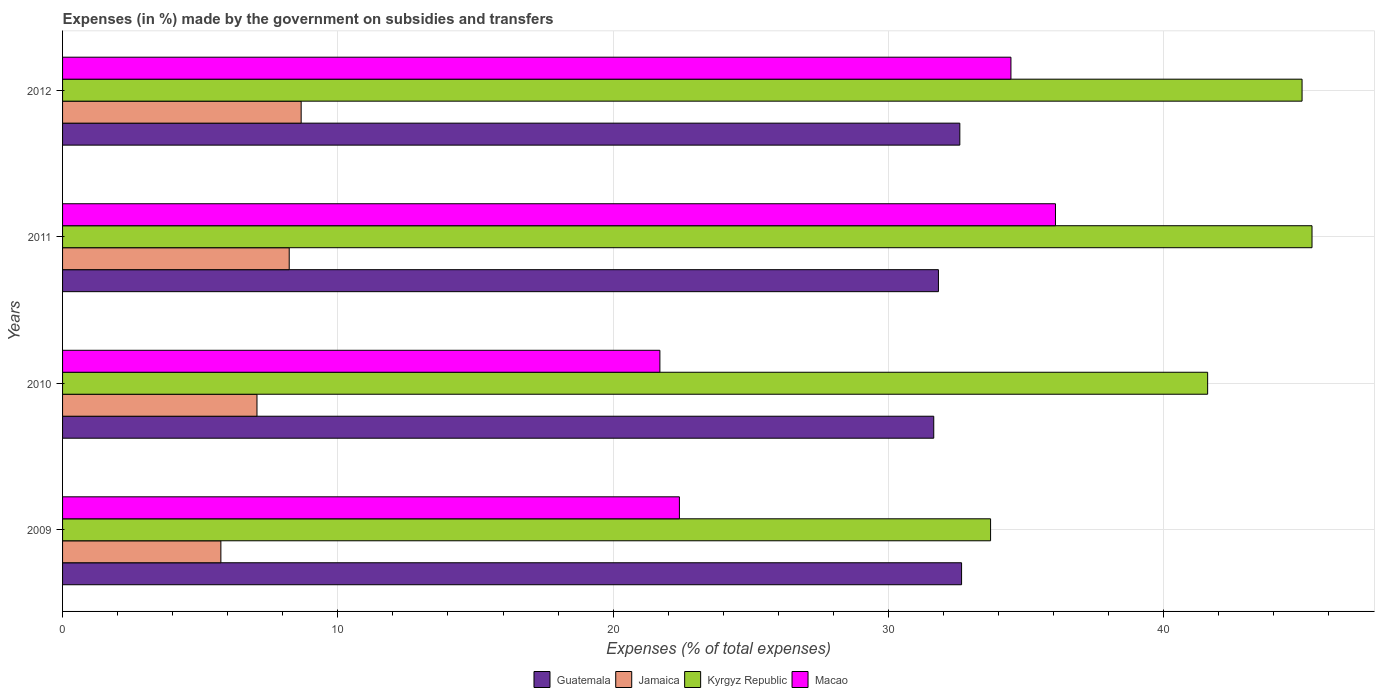How many different coloured bars are there?
Ensure brevity in your answer.  4. How many groups of bars are there?
Offer a very short reply. 4. Are the number of bars on each tick of the Y-axis equal?
Ensure brevity in your answer.  Yes. How many bars are there on the 3rd tick from the top?
Offer a very short reply. 4. What is the label of the 1st group of bars from the top?
Your answer should be very brief. 2012. What is the percentage of expenses made by the government on subsidies and transfers in Kyrgyz Republic in 2012?
Provide a short and direct response. 45.03. Across all years, what is the maximum percentage of expenses made by the government on subsidies and transfers in Jamaica?
Ensure brevity in your answer.  8.67. Across all years, what is the minimum percentage of expenses made by the government on subsidies and transfers in Guatemala?
Ensure brevity in your answer.  31.65. In which year was the percentage of expenses made by the government on subsidies and transfers in Kyrgyz Republic maximum?
Your answer should be compact. 2011. In which year was the percentage of expenses made by the government on subsidies and transfers in Jamaica minimum?
Your answer should be compact. 2009. What is the total percentage of expenses made by the government on subsidies and transfers in Macao in the graph?
Your response must be concise. 114.63. What is the difference between the percentage of expenses made by the government on subsidies and transfers in Jamaica in 2011 and that in 2012?
Offer a terse response. -0.43. What is the difference between the percentage of expenses made by the government on subsidies and transfers in Jamaica in 2010 and the percentage of expenses made by the government on subsidies and transfers in Guatemala in 2012?
Offer a very short reply. -25.53. What is the average percentage of expenses made by the government on subsidies and transfers in Guatemala per year?
Ensure brevity in your answer.  32.18. In the year 2010, what is the difference between the percentage of expenses made by the government on subsidies and transfers in Kyrgyz Republic and percentage of expenses made by the government on subsidies and transfers in Jamaica?
Keep it short and to the point. 34.53. What is the ratio of the percentage of expenses made by the government on subsidies and transfers in Kyrgyz Republic in 2009 to that in 2012?
Give a very brief answer. 0.75. What is the difference between the highest and the second highest percentage of expenses made by the government on subsidies and transfers in Guatemala?
Keep it short and to the point. 0.06. What is the difference between the highest and the lowest percentage of expenses made by the government on subsidies and transfers in Jamaica?
Your answer should be compact. 2.92. What does the 4th bar from the top in 2012 represents?
Provide a succinct answer. Guatemala. What does the 4th bar from the bottom in 2012 represents?
Your answer should be very brief. Macao. Is it the case that in every year, the sum of the percentage of expenses made by the government on subsidies and transfers in Guatemala and percentage of expenses made by the government on subsidies and transfers in Macao is greater than the percentage of expenses made by the government on subsidies and transfers in Kyrgyz Republic?
Provide a succinct answer. Yes. Are all the bars in the graph horizontal?
Offer a very short reply. Yes. Are the values on the major ticks of X-axis written in scientific E-notation?
Offer a terse response. No. Does the graph contain grids?
Ensure brevity in your answer.  Yes. What is the title of the graph?
Provide a short and direct response. Expenses (in %) made by the government on subsidies and transfers. What is the label or title of the X-axis?
Provide a short and direct response. Expenses (% of total expenses). What is the label or title of the Y-axis?
Your answer should be compact. Years. What is the Expenses (% of total expenses) in Guatemala in 2009?
Offer a terse response. 32.66. What is the Expenses (% of total expenses) in Jamaica in 2009?
Keep it short and to the point. 5.75. What is the Expenses (% of total expenses) in Kyrgyz Republic in 2009?
Give a very brief answer. 33.71. What is the Expenses (% of total expenses) of Macao in 2009?
Keep it short and to the point. 22.41. What is the Expenses (% of total expenses) of Guatemala in 2010?
Keep it short and to the point. 31.65. What is the Expenses (% of total expenses) in Jamaica in 2010?
Give a very brief answer. 7.06. What is the Expenses (% of total expenses) in Kyrgyz Republic in 2010?
Offer a very short reply. 41.6. What is the Expenses (% of total expenses) in Macao in 2010?
Your answer should be compact. 21.7. What is the Expenses (% of total expenses) of Guatemala in 2011?
Provide a succinct answer. 31.82. What is the Expenses (% of total expenses) in Jamaica in 2011?
Give a very brief answer. 8.23. What is the Expenses (% of total expenses) of Kyrgyz Republic in 2011?
Make the answer very short. 45.39. What is the Expenses (% of total expenses) in Macao in 2011?
Ensure brevity in your answer.  36.07. What is the Expenses (% of total expenses) in Guatemala in 2012?
Provide a succinct answer. 32.59. What is the Expenses (% of total expenses) of Jamaica in 2012?
Ensure brevity in your answer.  8.67. What is the Expenses (% of total expenses) of Kyrgyz Republic in 2012?
Give a very brief answer. 45.03. What is the Expenses (% of total expenses) of Macao in 2012?
Provide a short and direct response. 34.45. Across all years, what is the maximum Expenses (% of total expenses) in Guatemala?
Give a very brief answer. 32.66. Across all years, what is the maximum Expenses (% of total expenses) of Jamaica?
Make the answer very short. 8.67. Across all years, what is the maximum Expenses (% of total expenses) in Kyrgyz Republic?
Provide a succinct answer. 45.39. Across all years, what is the maximum Expenses (% of total expenses) in Macao?
Your answer should be compact. 36.07. Across all years, what is the minimum Expenses (% of total expenses) in Guatemala?
Your answer should be very brief. 31.65. Across all years, what is the minimum Expenses (% of total expenses) in Jamaica?
Offer a very short reply. 5.75. Across all years, what is the minimum Expenses (% of total expenses) of Kyrgyz Republic?
Ensure brevity in your answer.  33.71. Across all years, what is the minimum Expenses (% of total expenses) in Macao?
Ensure brevity in your answer.  21.7. What is the total Expenses (% of total expenses) in Guatemala in the graph?
Ensure brevity in your answer.  128.72. What is the total Expenses (% of total expenses) in Jamaica in the graph?
Give a very brief answer. 29.71. What is the total Expenses (% of total expenses) in Kyrgyz Republic in the graph?
Provide a succinct answer. 165.72. What is the total Expenses (% of total expenses) in Macao in the graph?
Ensure brevity in your answer.  114.63. What is the difference between the Expenses (% of total expenses) in Guatemala in 2009 and that in 2010?
Make the answer very short. 1.01. What is the difference between the Expenses (% of total expenses) in Jamaica in 2009 and that in 2010?
Make the answer very short. -1.31. What is the difference between the Expenses (% of total expenses) of Kyrgyz Republic in 2009 and that in 2010?
Keep it short and to the point. -7.88. What is the difference between the Expenses (% of total expenses) in Macao in 2009 and that in 2010?
Keep it short and to the point. 0.71. What is the difference between the Expenses (% of total expenses) of Guatemala in 2009 and that in 2011?
Your answer should be compact. 0.84. What is the difference between the Expenses (% of total expenses) in Jamaica in 2009 and that in 2011?
Ensure brevity in your answer.  -2.48. What is the difference between the Expenses (% of total expenses) in Kyrgyz Republic in 2009 and that in 2011?
Provide a short and direct response. -11.68. What is the difference between the Expenses (% of total expenses) of Macao in 2009 and that in 2011?
Your answer should be compact. -13.66. What is the difference between the Expenses (% of total expenses) of Guatemala in 2009 and that in 2012?
Make the answer very short. 0.06. What is the difference between the Expenses (% of total expenses) in Jamaica in 2009 and that in 2012?
Your answer should be compact. -2.92. What is the difference between the Expenses (% of total expenses) of Kyrgyz Republic in 2009 and that in 2012?
Your answer should be very brief. -11.32. What is the difference between the Expenses (% of total expenses) in Macao in 2009 and that in 2012?
Offer a very short reply. -12.04. What is the difference between the Expenses (% of total expenses) of Guatemala in 2010 and that in 2011?
Ensure brevity in your answer.  -0.17. What is the difference between the Expenses (% of total expenses) of Jamaica in 2010 and that in 2011?
Provide a succinct answer. -1.17. What is the difference between the Expenses (% of total expenses) in Kyrgyz Republic in 2010 and that in 2011?
Keep it short and to the point. -3.79. What is the difference between the Expenses (% of total expenses) of Macao in 2010 and that in 2011?
Keep it short and to the point. -14.37. What is the difference between the Expenses (% of total expenses) in Guatemala in 2010 and that in 2012?
Make the answer very short. -0.95. What is the difference between the Expenses (% of total expenses) of Jamaica in 2010 and that in 2012?
Offer a terse response. -1.6. What is the difference between the Expenses (% of total expenses) in Kyrgyz Republic in 2010 and that in 2012?
Provide a short and direct response. -3.43. What is the difference between the Expenses (% of total expenses) in Macao in 2010 and that in 2012?
Provide a short and direct response. -12.75. What is the difference between the Expenses (% of total expenses) in Guatemala in 2011 and that in 2012?
Give a very brief answer. -0.78. What is the difference between the Expenses (% of total expenses) in Jamaica in 2011 and that in 2012?
Provide a succinct answer. -0.43. What is the difference between the Expenses (% of total expenses) in Kyrgyz Republic in 2011 and that in 2012?
Offer a terse response. 0.36. What is the difference between the Expenses (% of total expenses) of Macao in 2011 and that in 2012?
Ensure brevity in your answer.  1.62. What is the difference between the Expenses (% of total expenses) in Guatemala in 2009 and the Expenses (% of total expenses) in Jamaica in 2010?
Your response must be concise. 25.6. What is the difference between the Expenses (% of total expenses) of Guatemala in 2009 and the Expenses (% of total expenses) of Kyrgyz Republic in 2010?
Keep it short and to the point. -8.94. What is the difference between the Expenses (% of total expenses) in Guatemala in 2009 and the Expenses (% of total expenses) in Macao in 2010?
Provide a succinct answer. 10.96. What is the difference between the Expenses (% of total expenses) of Jamaica in 2009 and the Expenses (% of total expenses) of Kyrgyz Republic in 2010?
Your answer should be very brief. -35.85. What is the difference between the Expenses (% of total expenses) of Jamaica in 2009 and the Expenses (% of total expenses) of Macao in 2010?
Your response must be concise. -15.95. What is the difference between the Expenses (% of total expenses) in Kyrgyz Republic in 2009 and the Expenses (% of total expenses) in Macao in 2010?
Provide a short and direct response. 12.01. What is the difference between the Expenses (% of total expenses) in Guatemala in 2009 and the Expenses (% of total expenses) in Jamaica in 2011?
Offer a terse response. 24.42. What is the difference between the Expenses (% of total expenses) in Guatemala in 2009 and the Expenses (% of total expenses) in Kyrgyz Republic in 2011?
Ensure brevity in your answer.  -12.73. What is the difference between the Expenses (% of total expenses) in Guatemala in 2009 and the Expenses (% of total expenses) in Macao in 2011?
Your response must be concise. -3.41. What is the difference between the Expenses (% of total expenses) of Jamaica in 2009 and the Expenses (% of total expenses) of Kyrgyz Republic in 2011?
Provide a succinct answer. -39.64. What is the difference between the Expenses (% of total expenses) of Jamaica in 2009 and the Expenses (% of total expenses) of Macao in 2011?
Offer a terse response. -30.32. What is the difference between the Expenses (% of total expenses) in Kyrgyz Republic in 2009 and the Expenses (% of total expenses) in Macao in 2011?
Keep it short and to the point. -2.36. What is the difference between the Expenses (% of total expenses) in Guatemala in 2009 and the Expenses (% of total expenses) in Jamaica in 2012?
Offer a very short reply. 23.99. What is the difference between the Expenses (% of total expenses) of Guatemala in 2009 and the Expenses (% of total expenses) of Kyrgyz Republic in 2012?
Give a very brief answer. -12.37. What is the difference between the Expenses (% of total expenses) of Guatemala in 2009 and the Expenses (% of total expenses) of Macao in 2012?
Your answer should be very brief. -1.79. What is the difference between the Expenses (% of total expenses) in Jamaica in 2009 and the Expenses (% of total expenses) in Kyrgyz Republic in 2012?
Your answer should be compact. -39.28. What is the difference between the Expenses (% of total expenses) of Jamaica in 2009 and the Expenses (% of total expenses) of Macao in 2012?
Your answer should be compact. -28.7. What is the difference between the Expenses (% of total expenses) in Kyrgyz Republic in 2009 and the Expenses (% of total expenses) in Macao in 2012?
Offer a very short reply. -0.74. What is the difference between the Expenses (% of total expenses) of Guatemala in 2010 and the Expenses (% of total expenses) of Jamaica in 2011?
Provide a short and direct response. 23.41. What is the difference between the Expenses (% of total expenses) in Guatemala in 2010 and the Expenses (% of total expenses) in Kyrgyz Republic in 2011?
Offer a very short reply. -13.74. What is the difference between the Expenses (% of total expenses) in Guatemala in 2010 and the Expenses (% of total expenses) in Macao in 2011?
Your answer should be compact. -4.42. What is the difference between the Expenses (% of total expenses) of Jamaica in 2010 and the Expenses (% of total expenses) of Kyrgyz Republic in 2011?
Your answer should be compact. -38.33. What is the difference between the Expenses (% of total expenses) in Jamaica in 2010 and the Expenses (% of total expenses) in Macao in 2011?
Ensure brevity in your answer.  -29.01. What is the difference between the Expenses (% of total expenses) in Kyrgyz Republic in 2010 and the Expenses (% of total expenses) in Macao in 2011?
Your response must be concise. 5.53. What is the difference between the Expenses (% of total expenses) of Guatemala in 2010 and the Expenses (% of total expenses) of Jamaica in 2012?
Provide a short and direct response. 22.98. What is the difference between the Expenses (% of total expenses) of Guatemala in 2010 and the Expenses (% of total expenses) of Kyrgyz Republic in 2012?
Keep it short and to the point. -13.38. What is the difference between the Expenses (% of total expenses) in Guatemala in 2010 and the Expenses (% of total expenses) in Macao in 2012?
Your answer should be compact. -2.8. What is the difference between the Expenses (% of total expenses) in Jamaica in 2010 and the Expenses (% of total expenses) in Kyrgyz Republic in 2012?
Provide a short and direct response. -37.96. What is the difference between the Expenses (% of total expenses) of Jamaica in 2010 and the Expenses (% of total expenses) of Macao in 2012?
Provide a short and direct response. -27.39. What is the difference between the Expenses (% of total expenses) in Kyrgyz Republic in 2010 and the Expenses (% of total expenses) in Macao in 2012?
Offer a very short reply. 7.15. What is the difference between the Expenses (% of total expenses) in Guatemala in 2011 and the Expenses (% of total expenses) in Jamaica in 2012?
Ensure brevity in your answer.  23.15. What is the difference between the Expenses (% of total expenses) in Guatemala in 2011 and the Expenses (% of total expenses) in Kyrgyz Republic in 2012?
Offer a terse response. -13.21. What is the difference between the Expenses (% of total expenses) of Guatemala in 2011 and the Expenses (% of total expenses) of Macao in 2012?
Make the answer very short. -2.63. What is the difference between the Expenses (% of total expenses) in Jamaica in 2011 and the Expenses (% of total expenses) in Kyrgyz Republic in 2012?
Provide a short and direct response. -36.79. What is the difference between the Expenses (% of total expenses) in Jamaica in 2011 and the Expenses (% of total expenses) in Macao in 2012?
Keep it short and to the point. -26.22. What is the difference between the Expenses (% of total expenses) in Kyrgyz Republic in 2011 and the Expenses (% of total expenses) in Macao in 2012?
Provide a succinct answer. 10.94. What is the average Expenses (% of total expenses) of Guatemala per year?
Your answer should be very brief. 32.18. What is the average Expenses (% of total expenses) in Jamaica per year?
Offer a very short reply. 7.43. What is the average Expenses (% of total expenses) in Kyrgyz Republic per year?
Provide a succinct answer. 41.43. What is the average Expenses (% of total expenses) in Macao per year?
Provide a short and direct response. 28.66. In the year 2009, what is the difference between the Expenses (% of total expenses) of Guatemala and Expenses (% of total expenses) of Jamaica?
Make the answer very short. 26.91. In the year 2009, what is the difference between the Expenses (% of total expenses) in Guatemala and Expenses (% of total expenses) in Kyrgyz Republic?
Your response must be concise. -1.05. In the year 2009, what is the difference between the Expenses (% of total expenses) in Guatemala and Expenses (% of total expenses) in Macao?
Ensure brevity in your answer.  10.25. In the year 2009, what is the difference between the Expenses (% of total expenses) in Jamaica and Expenses (% of total expenses) in Kyrgyz Republic?
Provide a short and direct response. -27.96. In the year 2009, what is the difference between the Expenses (% of total expenses) of Jamaica and Expenses (% of total expenses) of Macao?
Your answer should be very brief. -16.66. In the year 2009, what is the difference between the Expenses (% of total expenses) of Kyrgyz Republic and Expenses (% of total expenses) of Macao?
Your response must be concise. 11.3. In the year 2010, what is the difference between the Expenses (% of total expenses) of Guatemala and Expenses (% of total expenses) of Jamaica?
Ensure brevity in your answer.  24.58. In the year 2010, what is the difference between the Expenses (% of total expenses) of Guatemala and Expenses (% of total expenses) of Kyrgyz Republic?
Keep it short and to the point. -9.95. In the year 2010, what is the difference between the Expenses (% of total expenses) in Guatemala and Expenses (% of total expenses) in Macao?
Ensure brevity in your answer.  9.95. In the year 2010, what is the difference between the Expenses (% of total expenses) in Jamaica and Expenses (% of total expenses) in Kyrgyz Republic?
Your answer should be compact. -34.53. In the year 2010, what is the difference between the Expenses (% of total expenses) in Jamaica and Expenses (% of total expenses) in Macao?
Your answer should be compact. -14.64. In the year 2010, what is the difference between the Expenses (% of total expenses) of Kyrgyz Republic and Expenses (% of total expenses) of Macao?
Ensure brevity in your answer.  19.9. In the year 2011, what is the difference between the Expenses (% of total expenses) in Guatemala and Expenses (% of total expenses) in Jamaica?
Your answer should be compact. 23.58. In the year 2011, what is the difference between the Expenses (% of total expenses) in Guatemala and Expenses (% of total expenses) in Kyrgyz Republic?
Keep it short and to the point. -13.57. In the year 2011, what is the difference between the Expenses (% of total expenses) in Guatemala and Expenses (% of total expenses) in Macao?
Ensure brevity in your answer.  -4.25. In the year 2011, what is the difference between the Expenses (% of total expenses) of Jamaica and Expenses (% of total expenses) of Kyrgyz Republic?
Your response must be concise. -37.16. In the year 2011, what is the difference between the Expenses (% of total expenses) of Jamaica and Expenses (% of total expenses) of Macao?
Your response must be concise. -27.84. In the year 2011, what is the difference between the Expenses (% of total expenses) of Kyrgyz Republic and Expenses (% of total expenses) of Macao?
Your answer should be compact. 9.32. In the year 2012, what is the difference between the Expenses (% of total expenses) in Guatemala and Expenses (% of total expenses) in Jamaica?
Give a very brief answer. 23.93. In the year 2012, what is the difference between the Expenses (% of total expenses) of Guatemala and Expenses (% of total expenses) of Kyrgyz Republic?
Provide a succinct answer. -12.43. In the year 2012, what is the difference between the Expenses (% of total expenses) in Guatemala and Expenses (% of total expenses) in Macao?
Keep it short and to the point. -1.86. In the year 2012, what is the difference between the Expenses (% of total expenses) in Jamaica and Expenses (% of total expenses) in Kyrgyz Republic?
Provide a succinct answer. -36.36. In the year 2012, what is the difference between the Expenses (% of total expenses) in Jamaica and Expenses (% of total expenses) in Macao?
Offer a terse response. -25.78. In the year 2012, what is the difference between the Expenses (% of total expenses) in Kyrgyz Republic and Expenses (% of total expenses) in Macao?
Give a very brief answer. 10.58. What is the ratio of the Expenses (% of total expenses) in Guatemala in 2009 to that in 2010?
Offer a terse response. 1.03. What is the ratio of the Expenses (% of total expenses) in Jamaica in 2009 to that in 2010?
Give a very brief answer. 0.81. What is the ratio of the Expenses (% of total expenses) of Kyrgyz Republic in 2009 to that in 2010?
Your response must be concise. 0.81. What is the ratio of the Expenses (% of total expenses) of Macao in 2009 to that in 2010?
Make the answer very short. 1.03. What is the ratio of the Expenses (% of total expenses) of Guatemala in 2009 to that in 2011?
Keep it short and to the point. 1.03. What is the ratio of the Expenses (% of total expenses) of Jamaica in 2009 to that in 2011?
Your answer should be compact. 0.7. What is the ratio of the Expenses (% of total expenses) in Kyrgyz Republic in 2009 to that in 2011?
Provide a short and direct response. 0.74. What is the ratio of the Expenses (% of total expenses) of Macao in 2009 to that in 2011?
Your response must be concise. 0.62. What is the ratio of the Expenses (% of total expenses) in Guatemala in 2009 to that in 2012?
Give a very brief answer. 1. What is the ratio of the Expenses (% of total expenses) of Jamaica in 2009 to that in 2012?
Your response must be concise. 0.66. What is the ratio of the Expenses (% of total expenses) in Kyrgyz Republic in 2009 to that in 2012?
Provide a succinct answer. 0.75. What is the ratio of the Expenses (% of total expenses) in Macao in 2009 to that in 2012?
Offer a terse response. 0.65. What is the ratio of the Expenses (% of total expenses) in Jamaica in 2010 to that in 2011?
Make the answer very short. 0.86. What is the ratio of the Expenses (% of total expenses) in Kyrgyz Republic in 2010 to that in 2011?
Your response must be concise. 0.92. What is the ratio of the Expenses (% of total expenses) in Macao in 2010 to that in 2011?
Your response must be concise. 0.6. What is the ratio of the Expenses (% of total expenses) in Guatemala in 2010 to that in 2012?
Your answer should be very brief. 0.97. What is the ratio of the Expenses (% of total expenses) in Jamaica in 2010 to that in 2012?
Provide a succinct answer. 0.81. What is the ratio of the Expenses (% of total expenses) in Kyrgyz Republic in 2010 to that in 2012?
Your answer should be very brief. 0.92. What is the ratio of the Expenses (% of total expenses) in Macao in 2010 to that in 2012?
Ensure brevity in your answer.  0.63. What is the ratio of the Expenses (% of total expenses) of Guatemala in 2011 to that in 2012?
Provide a short and direct response. 0.98. What is the ratio of the Expenses (% of total expenses) in Jamaica in 2011 to that in 2012?
Give a very brief answer. 0.95. What is the ratio of the Expenses (% of total expenses) of Macao in 2011 to that in 2012?
Ensure brevity in your answer.  1.05. What is the difference between the highest and the second highest Expenses (% of total expenses) of Guatemala?
Provide a short and direct response. 0.06. What is the difference between the highest and the second highest Expenses (% of total expenses) of Jamaica?
Ensure brevity in your answer.  0.43. What is the difference between the highest and the second highest Expenses (% of total expenses) in Kyrgyz Republic?
Keep it short and to the point. 0.36. What is the difference between the highest and the second highest Expenses (% of total expenses) in Macao?
Make the answer very short. 1.62. What is the difference between the highest and the lowest Expenses (% of total expenses) of Guatemala?
Your response must be concise. 1.01. What is the difference between the highest and the lowest Expenses (% of total expenses) of Jamaica?
Provide a short and direct response. 2.92. What is the difference between the highest and the lowest Expenses (% of total expenses) in Kyrgyz Republic?
Offer a very short reply. 11.68. What is the difference between the highest and the lowest Expenses (% of total expenses) in Macao?
Give a very brief answer. 14.37. 